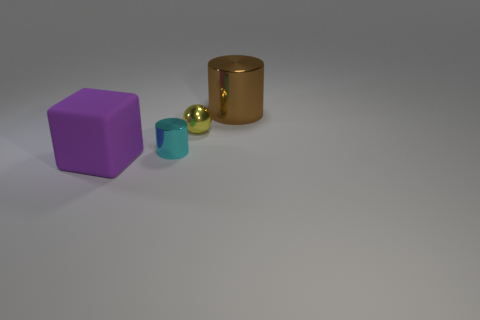What is the material of the block that is the same size as the brown thing?
Provide a short and direct response. Rubber. Are there more tiny cyan cylinders on the right side of the purple matte thing than tiny shiny cylinders that are behind the tiny yellow shiny sphere?
Provide a succinct answer. Yes. Is there another big thing that has the same shape as the large purple rubber object?
Keep it short and to the point. No. There is a cyan shiny object that is the same size as the yellow object; what is its shape?
Your answer should be compact. Cylinder. What is the shape of the big thing that is on the left side of the tiny ball?
Provide a succinct answer. Cube. Are there fewer tiny yellow objects that are to the left of the small metal cylinder than large objects in front of the large brown shiny cylinder?
Ensure brevity in your answer.  Yes. There is a yellow metallic ball; is it the same size as the thing in front of the cyan object?
Your answer should be compact. No. How many brown cylinders are the same size as the brown object?
Keep it short and to the point. 0. There is a small object that is the same material as the yellow ball; what color is it?
Provide a succinct answer. Cyan. Are there more big cylinders than green matte objects?
Provide a short and direct response. Yes. 